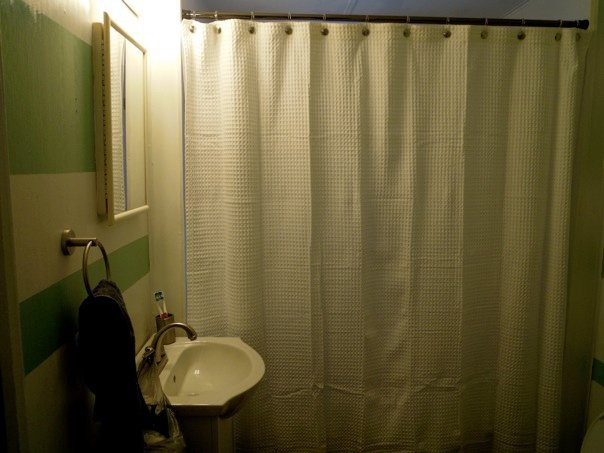Describe the objects in this image and their specific colors. I can see sink in darkgreen, olive, and black tones, cup in black, olive, maroon, and darkgreen tones, toothbrush in darkgreen, olive, black, and maroon tones, and toothbrush in darkgreen, olive, black, and maroon tones in this image. 